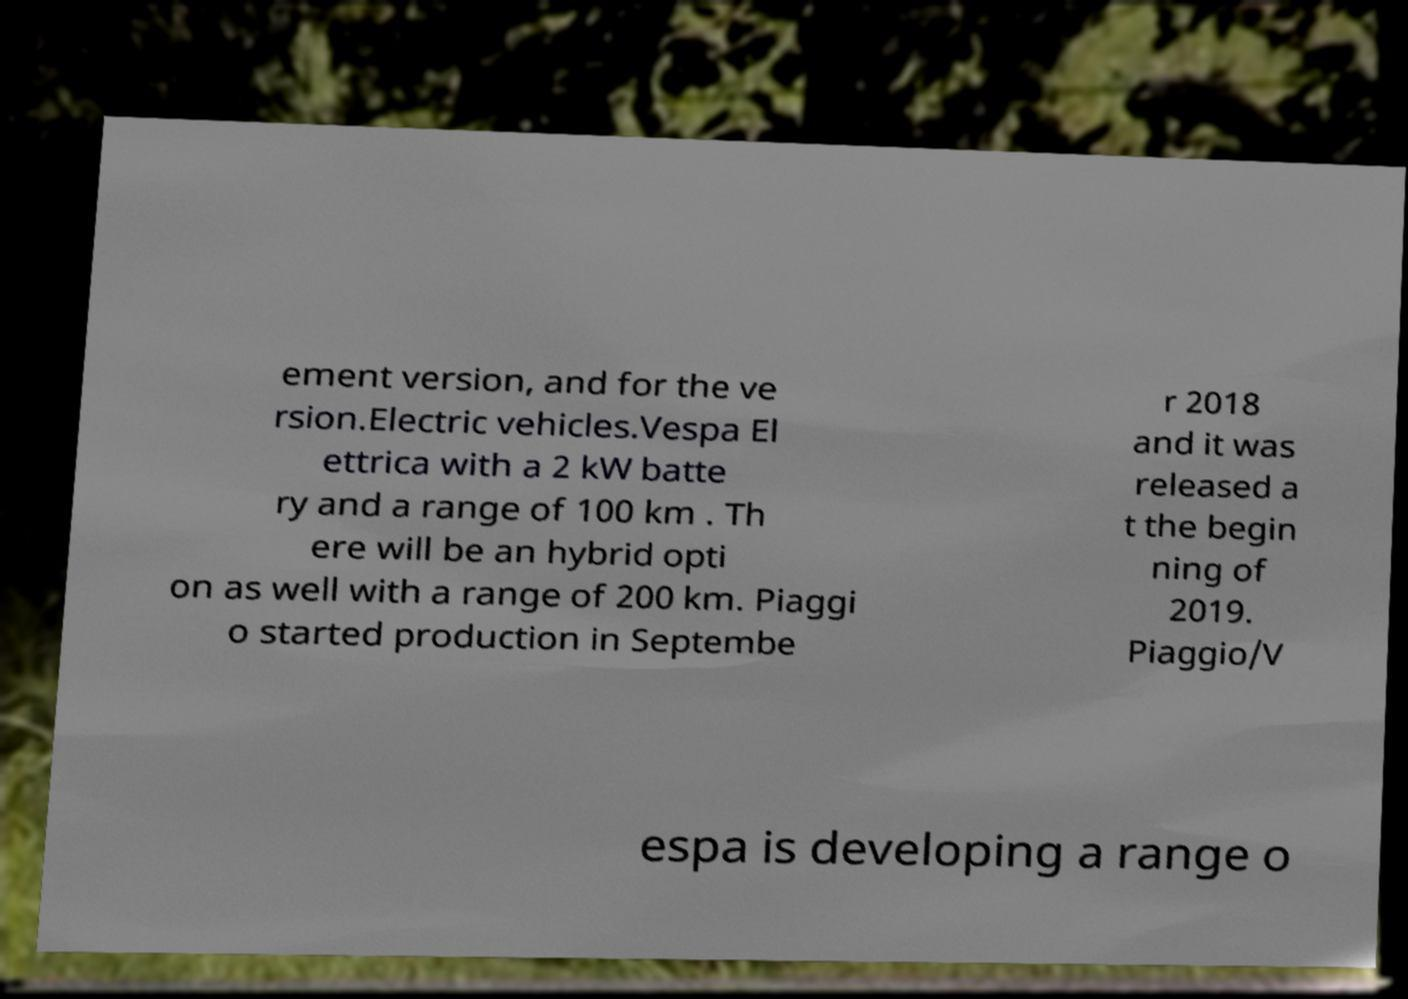Could you extract and type out the text from this image? ement version, and for the ve rsion.Electric vehicles.Vespa El ettrica with a 2 kW batte ry and a range of 100 km . Th ere will be an hybrid opti on as well with a range of 200 km. Piaggi o started production in Septembe r 2018 and it was released a t the begin ning of 2019. Piaggio/V espa is developing a range o 